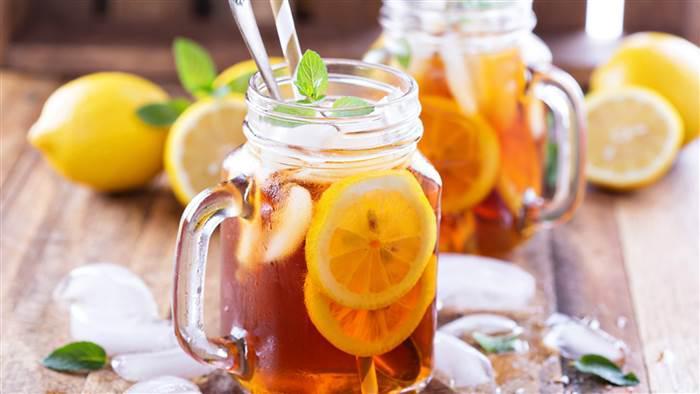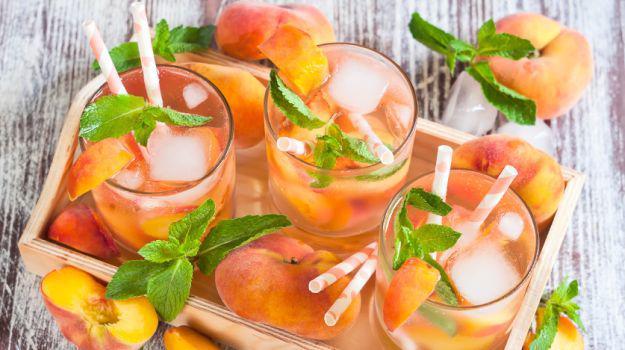The first image is the image on the left, the second image is the image on the right. Examine the images to the left and right. Is the description "The left image features a beverage in a jar-type glass with a handle, and the beverage has a straw in it and a green leaf for garnish." accurate? Answer yes or no. Yes. The first image is the image on the left, the second image is the image on the right. For the images shown, is this caption "One straw is at least partly red." true? Answer yes or no. No. 